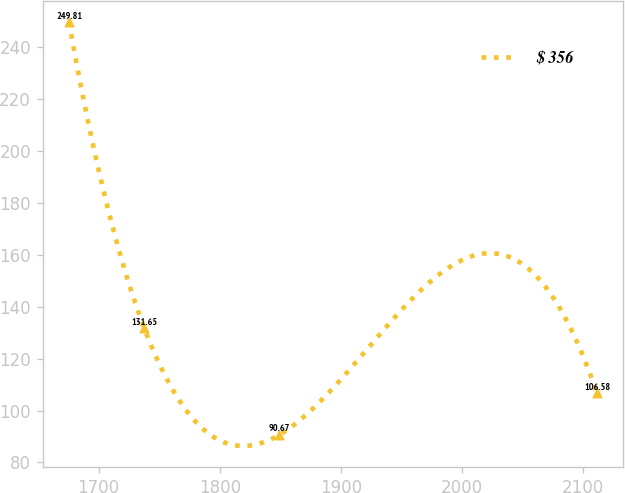Convert chart. <chart><loc_0><loc_0><loc_500><loc_500><line_chart><ecel><fcel>$ 356<nl><fcel>1675.58<fcel>249.81<nl><fcel>1737.83<fcel>131.65<nl><fcel>1849.31<fcel>90.67<nl><fcel>2111.48<fcel>106.58<nl></chart> 